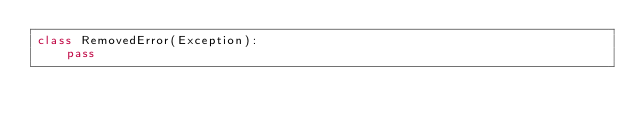Convert code to text. <code><loc_0><loc_0><loc_500><loc_500><_Python_>class RemovedError(Exception):
    pass
</code> 